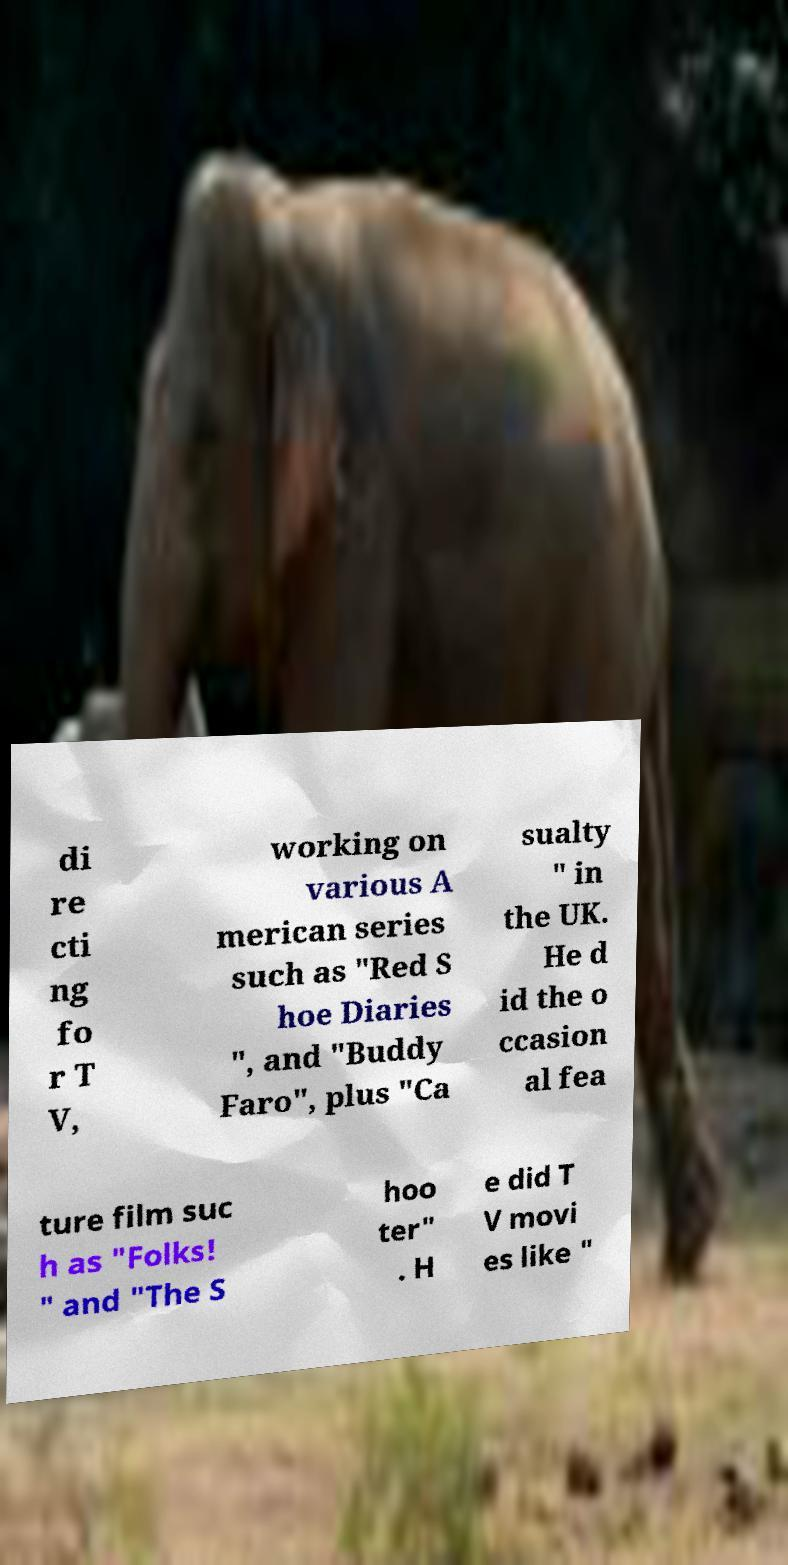I need the written content from this picture converted into text. Can you do that? di re cti ng fo r T V, working on various A merican series such as "Red S hoe Diaries ", and "Buddy Faro", plus "Ca sualty " in the UK. He d id the o ccasion al fea ture film suc h as "Folks! " and "The S hoo ter" . H e did T V movi es like " 